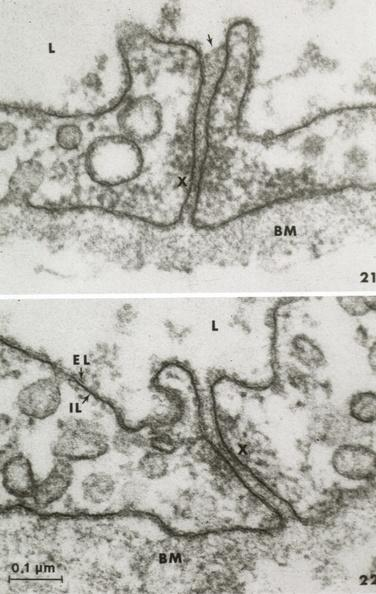s this image present?
Answer the question using a single word or phrase. No 